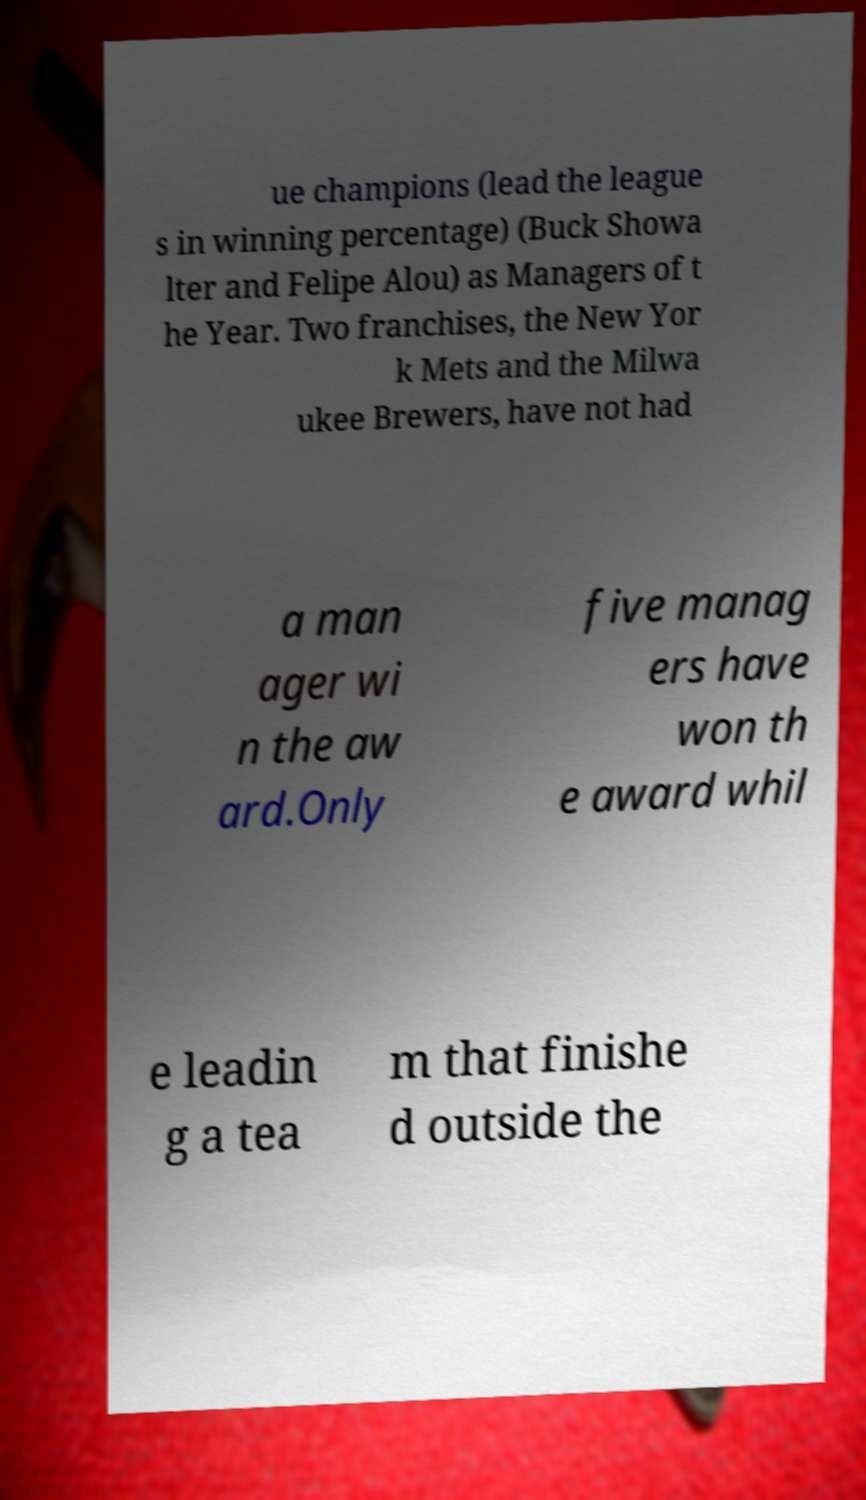Could you assist in decoding the text presented in this image and type it out clearly? ue champions (lead the league s in winning percentage) (Buck Showa lter and Felipe Alou) as Managers of t he Year. Two franchises, the New Yor k Mets and the Milwa ukee Brewers, have not had a man ager wi n the aw ard.Only five manag ers have won th e award whil e leadin g a tea m that finishe d outside the 